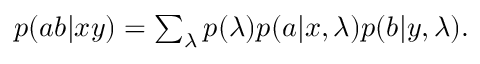<formula> <loc_0><loc_0><loc_500><loc_500>\begin{array} { r } { p ( a b | x y ) = \sum _ { \lambda } p ( \lambda ) p ( a | x , \lambda ) p ( b | y , \lambda ) . } \end{array}</formula> 